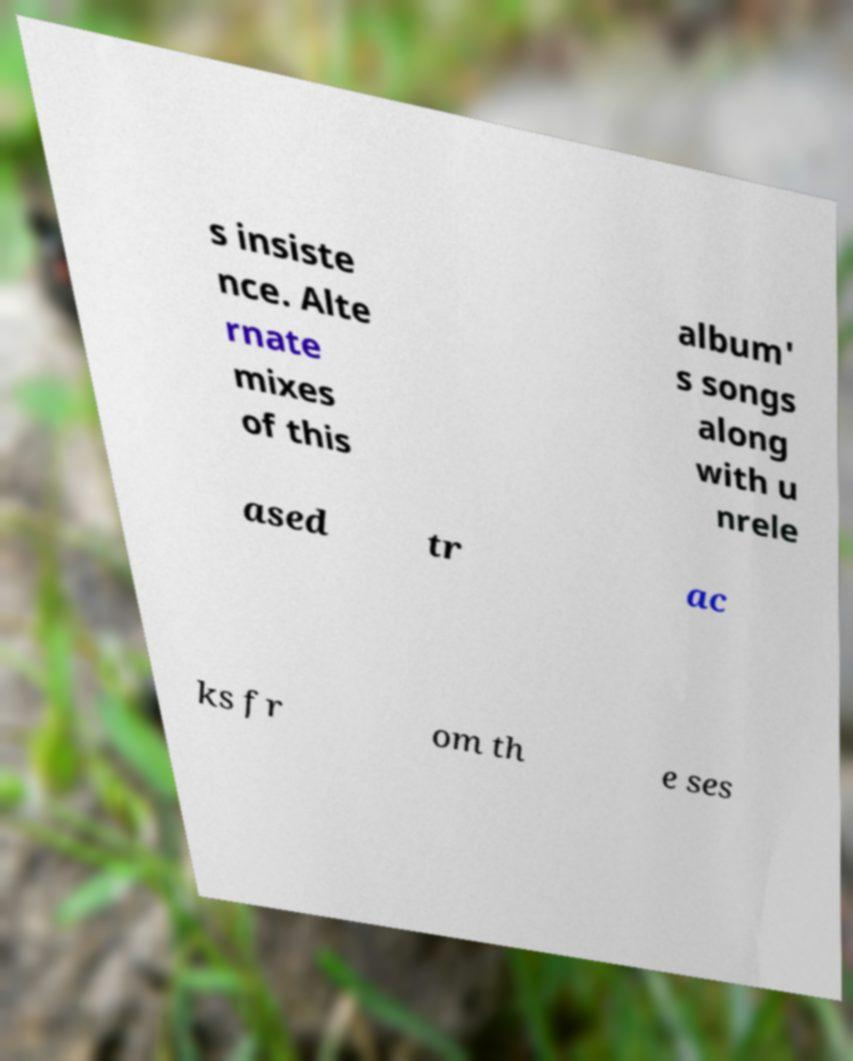Can you accurately transcribe the text from the provided image for me? s insiste nce. Alte rnate mixes of this album' s songs along with u nrele ased tr ac ks fr om th e ses 